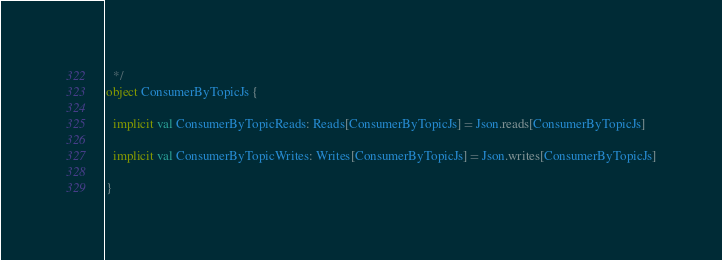Convert code to text. <code><loc_0><loc_0><loc_500><loc_500><_Scala_>  */
object ConsumerByTopicJs {

  implicit val ConsumerByTopicReads: Reads[ConsumerByTopicJs] = Json.reads[ConsumerByTopicJs]

  implicit val ConsumerByTopicWrites: Writes[ConsumerByTopicJs] = Json.writes[ConsumerByTopicJs]

}
</code> 